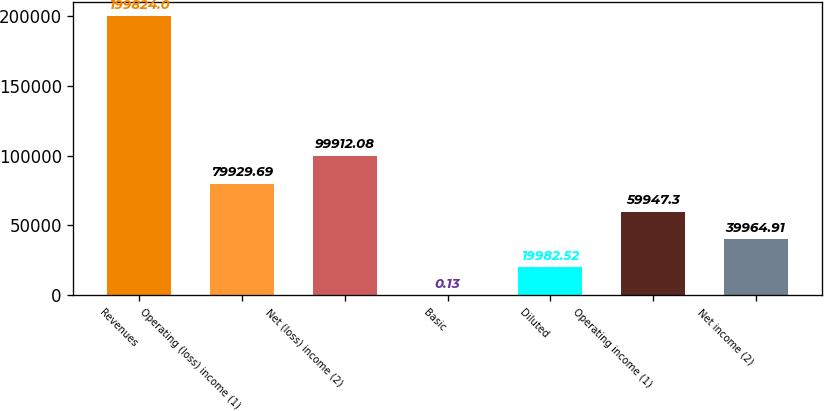Convert chart to OTSL. <chart><loc_0><loc_0><loc_500><loc_500><bar_chart><fcel>Revenues<fcel>Operating (loss) income (1)<fcel>Net (loss) income (2)<fcel>Basic<fcel>Diluted<fcel>Operating income (1)<fcel>Net income (2)<nl><fcel>199824<fcel>79929.7<fcel>99912.1<fcel>0.13<fcel>19982.5<fcel>59947.3<fcel>39964.9<nl></chart> 